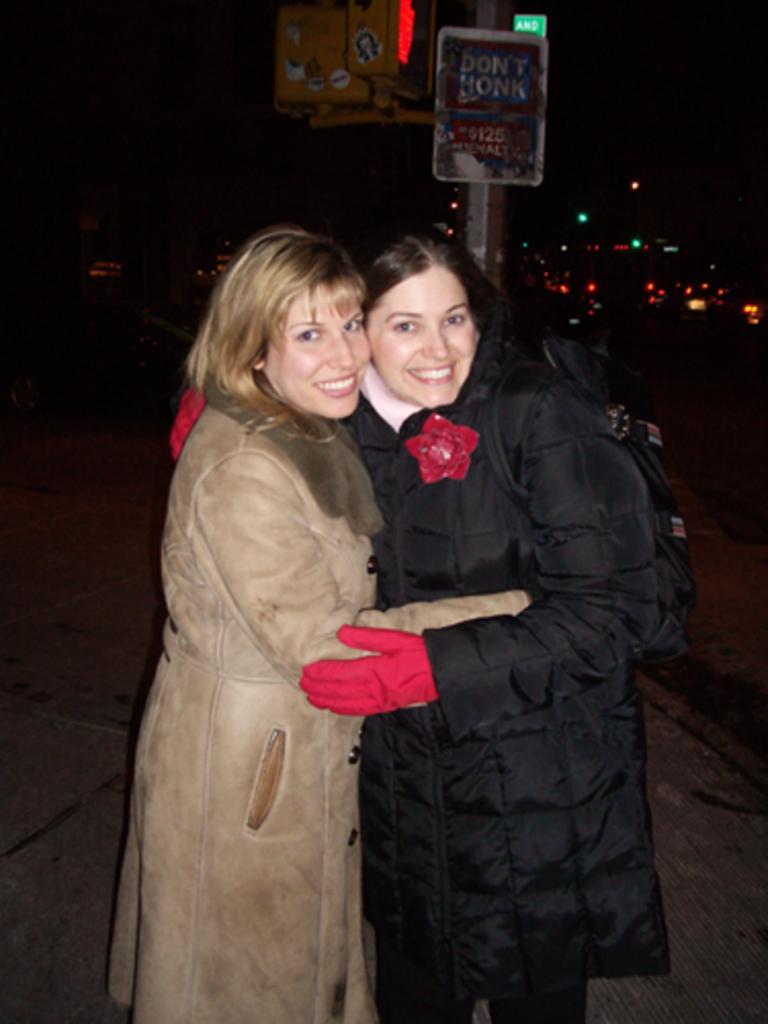Can you describe this image briefly? As we can see in the image in the front there are two women standing. In the background there is a sign board and lights. The background is dark. 